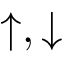Convert formula to latex. <formula><loc_0><loc_0><loc_500><loc_500>\uparrow , \downarrow</formula> 